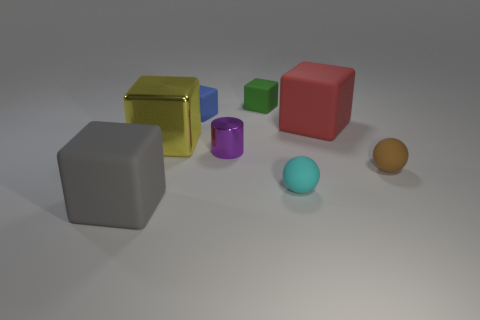Subtract all red blocks. How many blocks are left? 4 Subtract 2 cubes. How many cubes are left? 3 Subtract all green matte cubes. How many cubes are left? 4 Subtract all green blocks. Subtract all cyan balls. How many blocks are left? 4 Add 1 gray blocks. How many objects exist? 9 Subtract all blocks. How many objects are left? 3 Add 6 matte cubes. How many matte cubes are left? 10 Add 6 small brown spheres. How many small brown spheres exist? 7 Subtract 0 purple balls. How many objects are left? 8 Subtract all purple metal objects. Subtract all tiny cylinders. How many objects are left? 6 